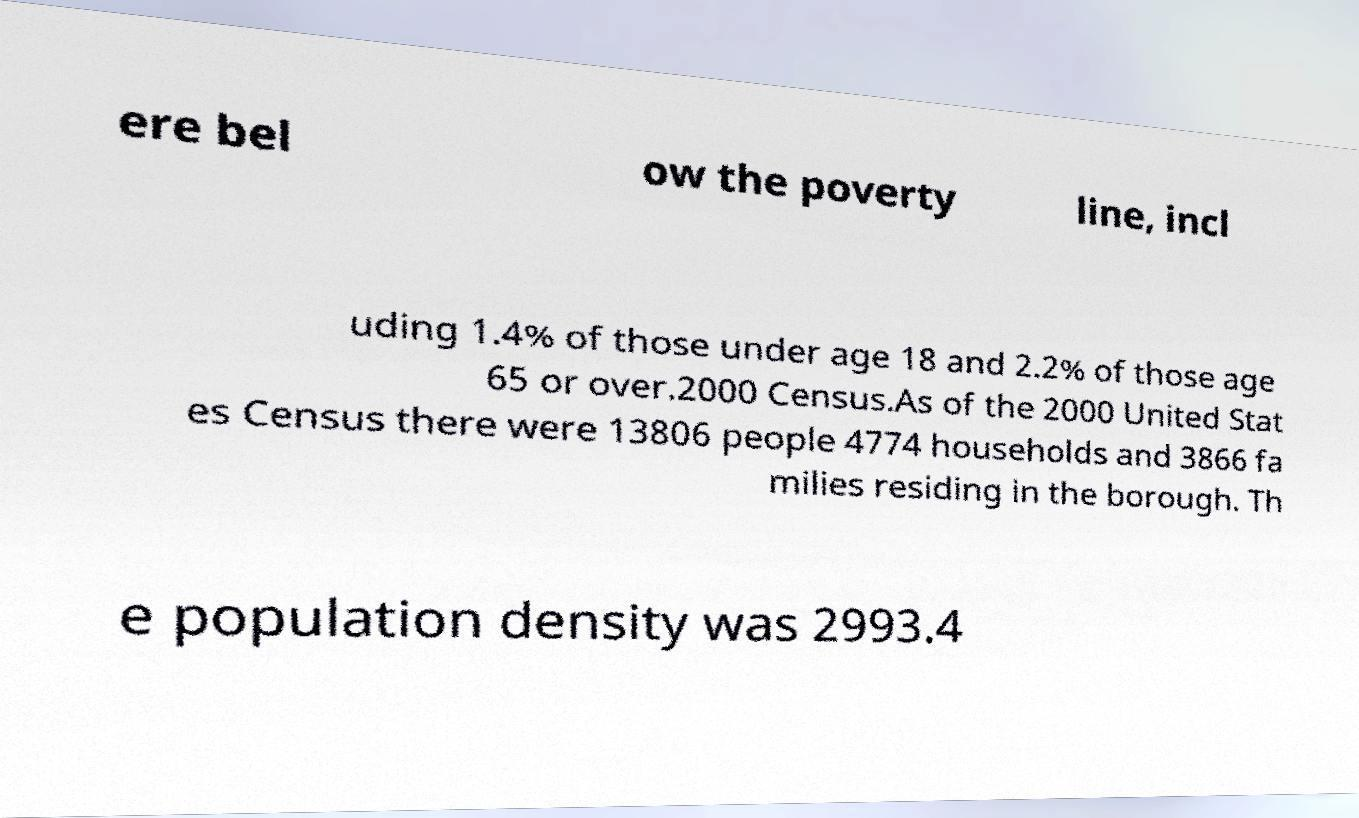Can you accurately transcribe the text from the provided image for me? ere bel ow the poverty line, incl uding 1.4% of those under age 18 and 2.2% of those age 65 or over.2000 Census.As of the 2000 United Stat es Census there were 13806 people 4774 households and 3866 fa milies residing in the borough. Th e population density was 2993.4 